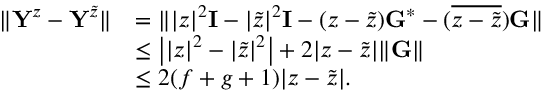Convert formula to latex. <formula><loc_0><loc_0><loc_500><loc_500>\begin{array} { r l } { \| Y ^ { z } - Y ^ { \tilde { z } } \| } & { = \| | z | ^ { 2 } I - | \tilde { z } | ^ { 2 } I - ( z - \tilde { z } ) G ^ { * } - ( \overline { { z - \tilde { z } } } ) G \| } \\ & { \leq \left | | z | ^ { 2 } - | \tilde { z } | ^ { 2 } \right | + 2 | z - \tilde { z } | \| G \| } \\ & { \leq 2 ( f + g + 1 ) | z - \tilde { z } | . } \end{array}</formula> 